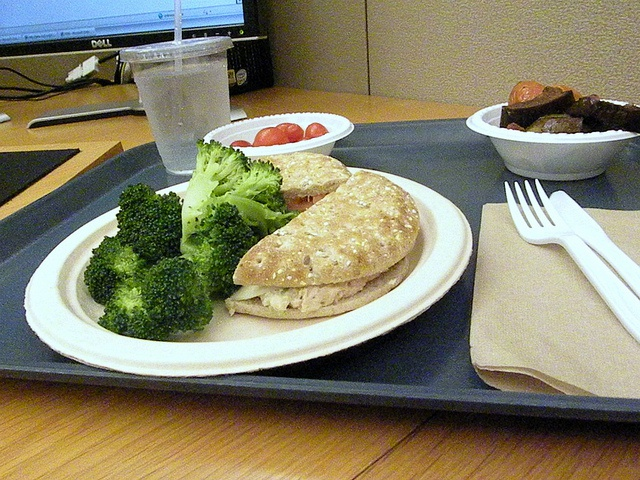Describe the objects in this image and their specific colors. I can see broccoli in lightblue, black, darkgreen, and olive tones, sandwich in lightblue, khaki, and tan tones, tv in lightblue and black tones, cup in lightblue, darkgray, and gray tones, and bowl in lightblue, white, gray, and darkgray tones in this image. 